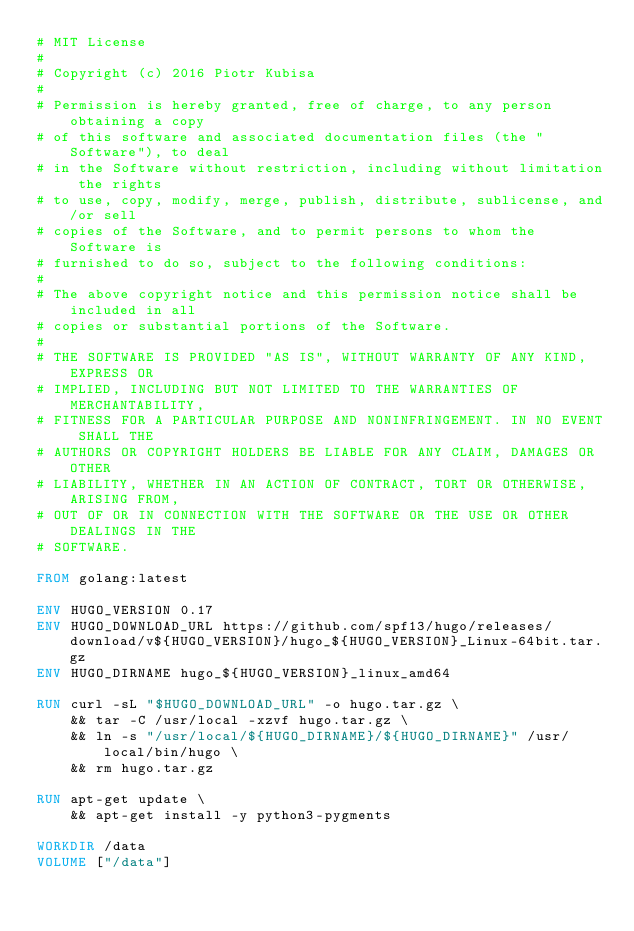Convert code to text. <code><loc_0><loc_0><loc_500><loc_500><_Dockerfile_># MIT License
# 
# Copyright (c) 2016 Piotr Kubisa
# 
# Permission is hereby granted, free of charge, to any person obtaining a copy
# of this software and associated documentation files (the "Software"), to deal
# in the Software without restriction, including without limitation the rights
# to use, copy, modify, merge, publish, distribute, sublicense, and/or sell
# copies of the Software, and to permit persons to whom the Software is
# furnished to do so, subject to the following conditions:
# 
# The above copyright notice and this permission notice shall be included in all
# copies or substantial portions of the Software.
# 
# THE SOFTWARE IS PROVIDED "AS IS", WITHOUT WARRANTY OF ANY KIND, EXPRESS OR
# IMPLIED, INCLUDING BUT NOT LIMITED TO THE WARRANTIES OF MERCHANTABILITY,
# FITNESS FOR A PARTICULAR PURPOSE AND NONINFRINGEMENT. IN NO EVENT SHALL THE
# AUTHORS OR COPYRIGHT HOLDERS BE LIABLE FOR ANY CLAIM, DAMAGES OR OTHER
# LIABILITY, WHETHER IN AN ACTION OF CONTRACT, TORT OR OTHERWISE, ARISING FROM,
# OUT OF OR IN CONNECTION WITH THE SOFTWARE OR THE USE OR OTHER DEALINGS IN THE
# SOFTWARE.

FROM golang:latest

ENV HUGO_VERSION 0.17
ENV HUGO_DOWNLOAD_URL https://github.com/spf13/hugo/releases/download/v${HUGO_VERSION}/hugo_${HUGO_VERSION}_Linux-64bit.tar.gz
ENV HUGO_DIRNAME hugo_${HUGO_VERSION}_linux_amd64

RUN curl -sL "$HUGO_DOWNLOAD_URL" -o hugo.tar.gz \ 
    && tar -C /usr/local -xzvf hugo.tar.gz \
    && ln -s "/usr/local/${HUGO_DIRNAME}/${HUGO_DIRNAME}" /usr/local/bin/hugo \
    && rm hugo.tar.gz

RUN apt-get update \
    && apt-get install -y python3-pygments

WORKDIR /data
VOLUME ["/data"]</code> 